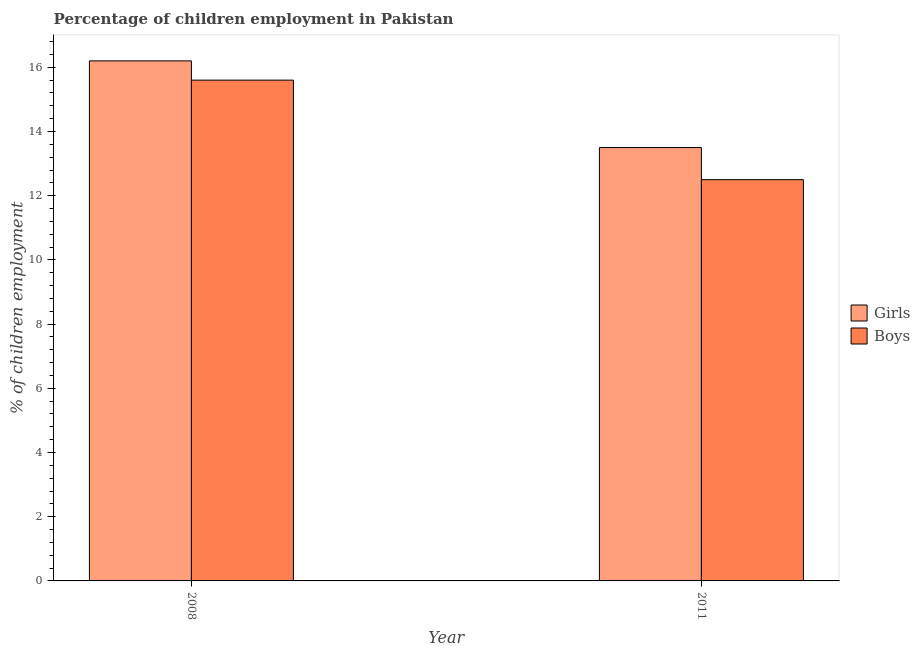How many different coloured bars are there?
Keep it short and to the point. 2. How many groups of bars are there?
Offer a very short reply. 2. What is the percentage of employed girls in 2011?
Provide a short and direct response. 13.5. Across all years, what is the minimum percentage of employed boys?
Your answer should be compact. 12.5. What is the total percentage of employed boys in the graph?
Offer a very short reply. 28.1. What is the difference between the percentage of employed girls in 2008 and that in 2011?
Ensure brevity in your answer.  2.7. What is the difference between the percentage of employed girls in 2011 and the percentage of employed boys in 2008?
Your answer should be very brief. -2.7. What is the average percentage of employed girls per year?
Keep it short and to the point. 14.85. What is the ratio of the percentage of employed girls in 2008 to that in 2011?
Offer a very short reply. 1.2. What does the 2nd bar from the left in 2011 represents?
Offer a very short reply. Boys. What does the 2nd bar from the right in 2011 represents?
Provide a short and direct response. Girls. How many bars are there?
Give a very brief answer. 4. Does the graph contain grids?
Provide a short and direct response. No. Where does the legend appear in the graph?
Your response must be concise. Center right. How many legend labels are there?
Offer a terse response. 2. What is the title of the graph?
Your response must be concise. Percentage of children employment in Pakistan. Does "Boys" appear as one of the legend labels in the graph?
Ensure brevity in your answer.  Yes. What is the label or title of the Y-axis?
Your response must be concise. % of children employment. What is the % of children employment in Girls in 2008?
Make the answer very short. 16.2. What is the % of children employment in Girls in 2011?
Your answer should be compact. 13.5. Across all years, what is the maximum % of children employment of Girls?
Offer a very short reply. 16.2. Across all years, what is the minimum % of children employment of Boys?
Keep it short and to the point. 12.5. What is the total % of children employment of Girls in the graph?
Offer a terse response. 29.7. What is the total % of children employment of Boys in the graph?
Your answer should be compact. 28.1. What is the difference between the % of children employment in Girls in 2008 and that in 2011?
Offer a very short reply. 2.7. What is the difference between the % of children employment of Boys in 2008 and that in 2011?
Provide a short and direct response. 3.1. What is the difference between the % of children employment of Girls in 2008 and the % of children employment of Boys in 2011?
Offer a terse response. 3.7. What is the average % of children employment of Girls per year?
Your answer should be very brief. 14.85. What is the average % of children employment of Boys per year?
Offer a terse response. 14.05. In the year 2011, what is the difference between the % of children employment of Girls and % of children employment of Boys?
Provide a succinct answer. 1. What is the ratio of the % of children employment in Girls in 2008 to that in 2011?
Give a very brief answer. 1.2. What is the ratio of the % of children employment of Boys in 2008 to that in 2011?
Make the answer very short. 1.25. What is the difference between the highest and the lowest % of children employment in Boys?
Your answer should be very brief. 3.1. 